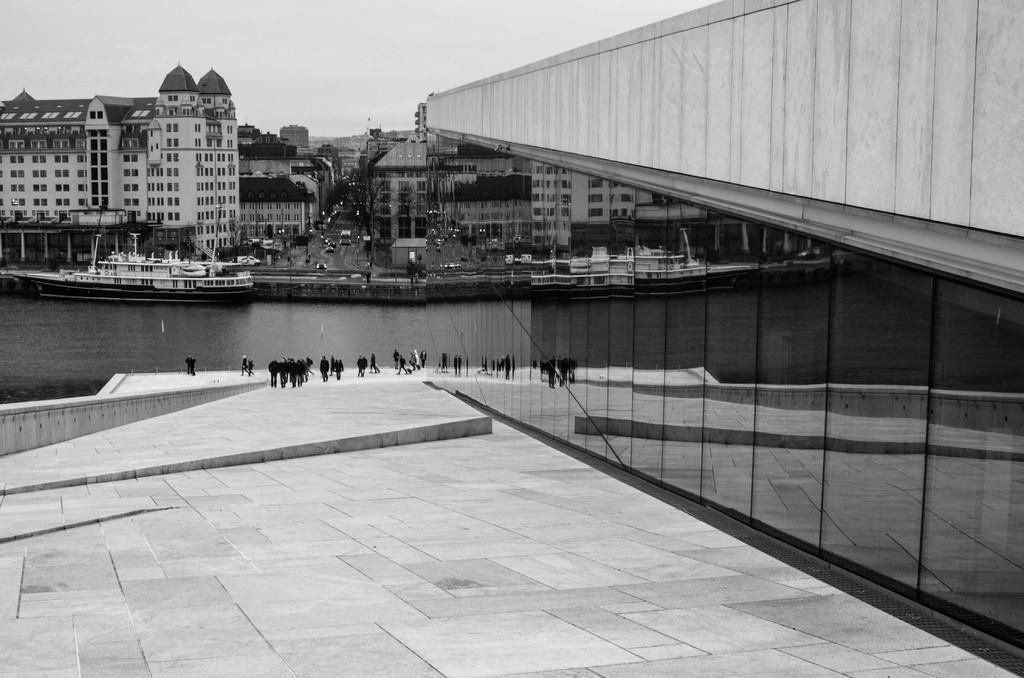What is the color scheme of the image? The image is black and white. What is the main subject of the image? There is a ship in the image. What can be seen in the background of the image? There is water visible in the image, as well as buildings, trees, and the sky. Are there any people in the image? Yes, there are persons on the floor in the image. What else can be seen in the image? Motor vehicles are present in the image. What type of jewel can be seen hanging from the ship's mast in the image? There is no jewel hanging from the ship's mast in the image; it is a black and white image with no visible jewelry. What type of cloud formation can be seen in the sky in the image? There is no specific cloud formation mentioned in the image; it only states that the sky is visible in the image. 